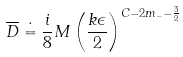Convert formula to latex. <formula><loc_0><loc_0><loc_500><loc_500>\overline { D } \doteq \frac { i } { 8 } M \left ( \frac { k \epsilon } { 2 } \right ) ^ { C - 2 m _ { - } - \frac { 3 } { 2 } }</formula> 